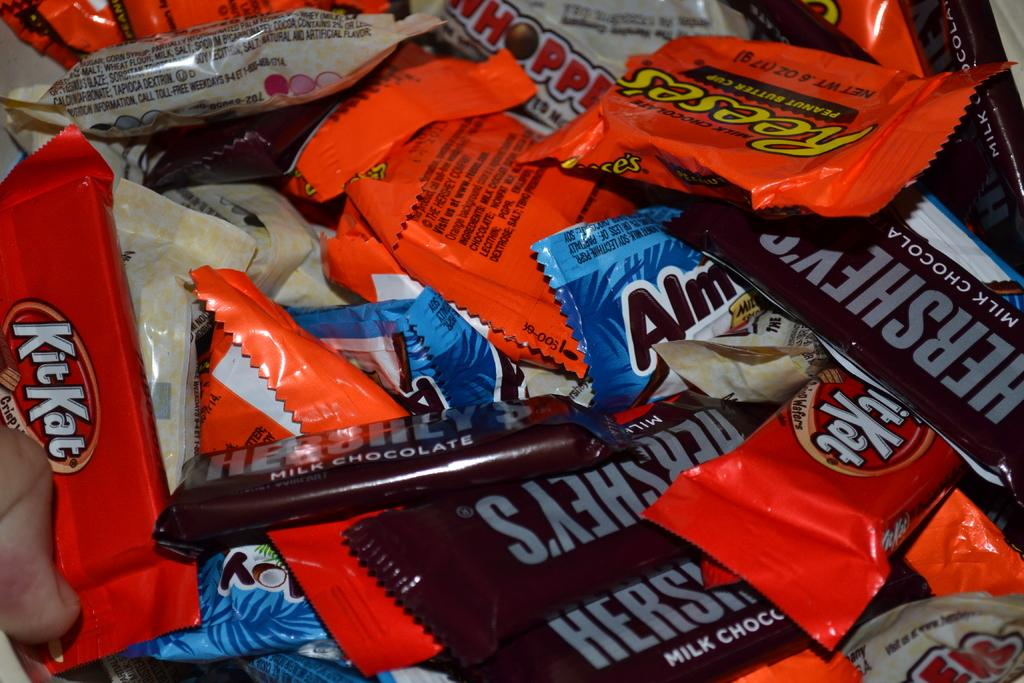What type of product is featured in the image? The image features chocolate packets. Can you describe the colors of the chocolate packets? Some of the chocolate packets are brown, orange, blue, black, and cream in color. What type of chair is depicted in the image? There is no chair present in the image; it only features chocolate packets. How does the flame interact with the chocolate packets in the image? There is no flame present in the image; it only features chocolate packets. 